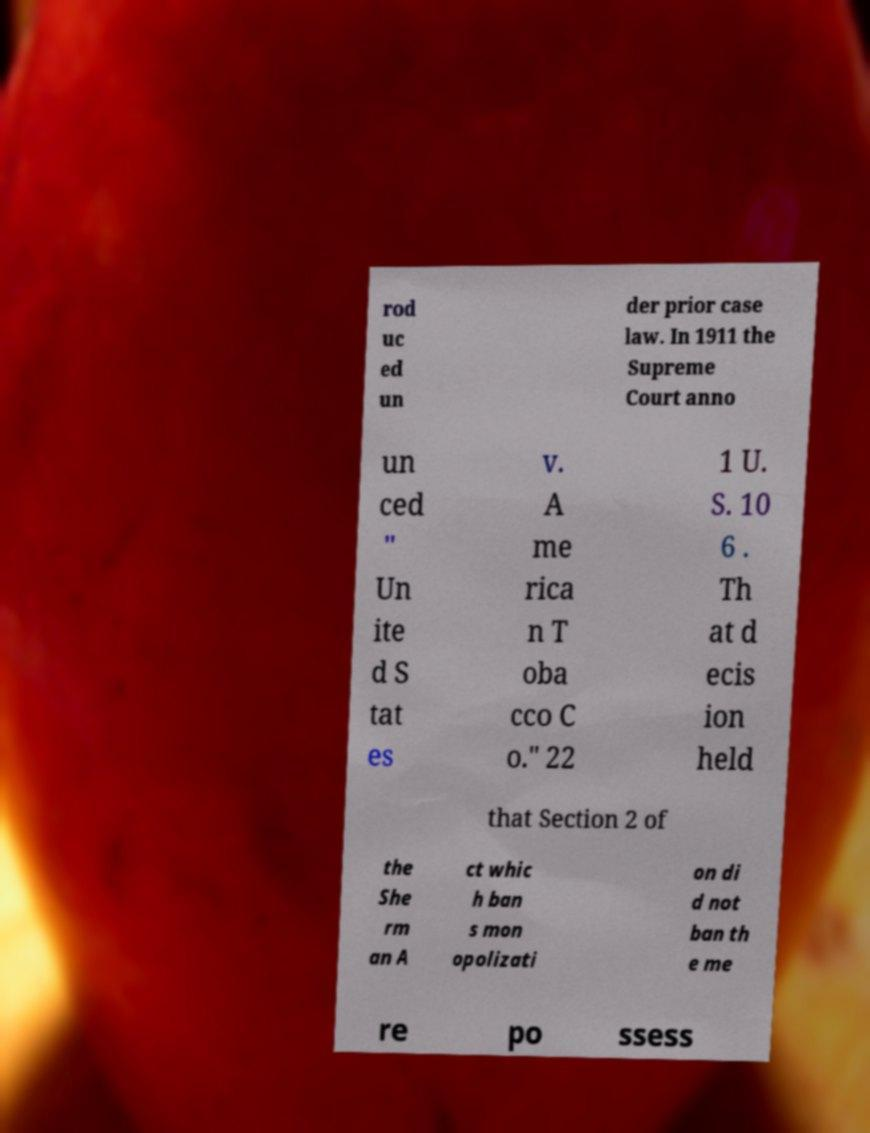Could you assist in decoding the text presented in this image and type it out clearly? rod uc ed un der prior case law. In 1911 the Supreme Court anno un ced " Un ite d S tat es v. A me rica n T oba cco C o." 22 1 U. S. 10 6 . Th at d ecis ion held that Section 2 of the She rm an A ct whic h ban s mon opolizati on di d not ban th e me re po ssess 